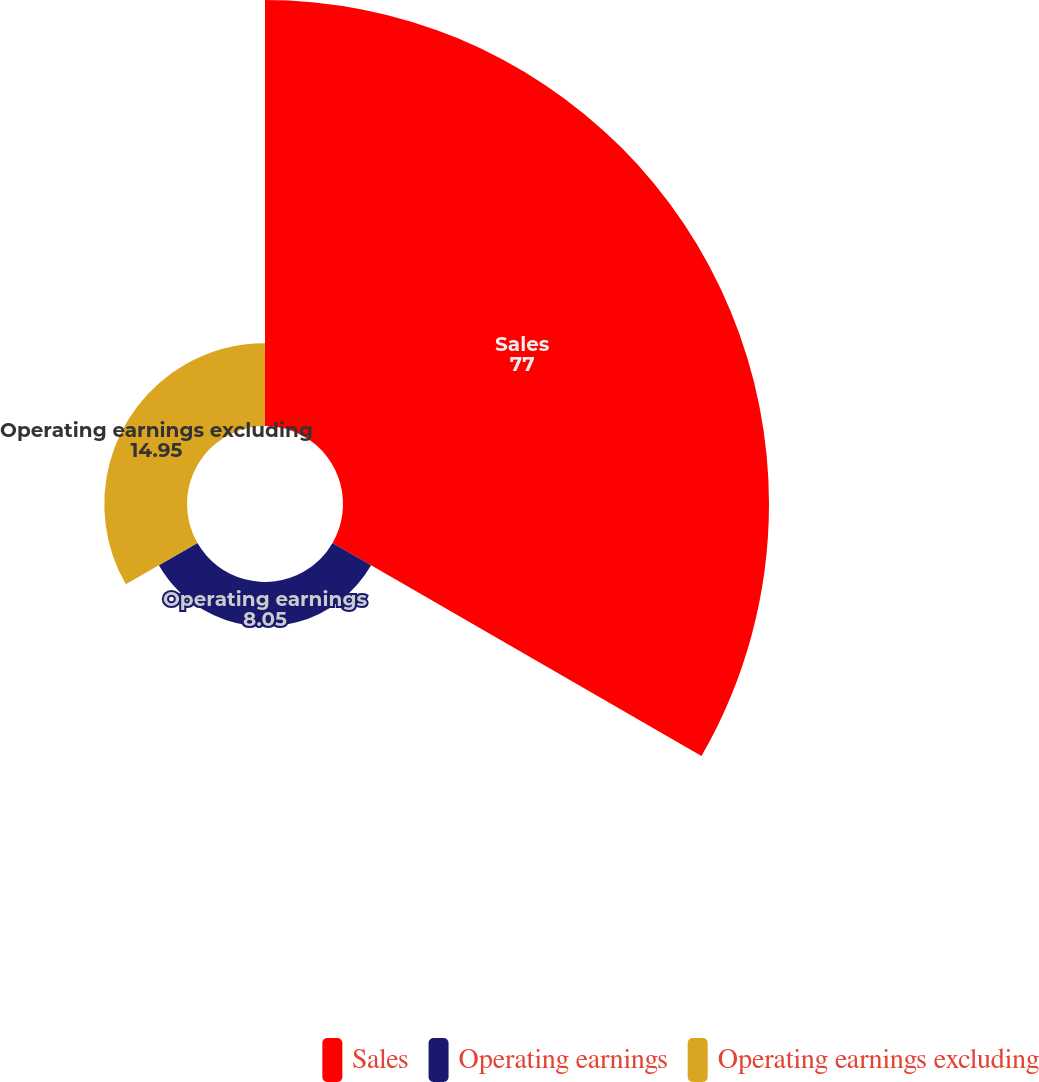<chart> <loc_0><loc_0><loc_500><loc_500><pie_chart><fcel>Sales<fcel>Operating earnings<fcel>Operating earnings excluding<nl><fcel>77.0%<fcel>8.05%<fcel>14.95%<nl></chart> 